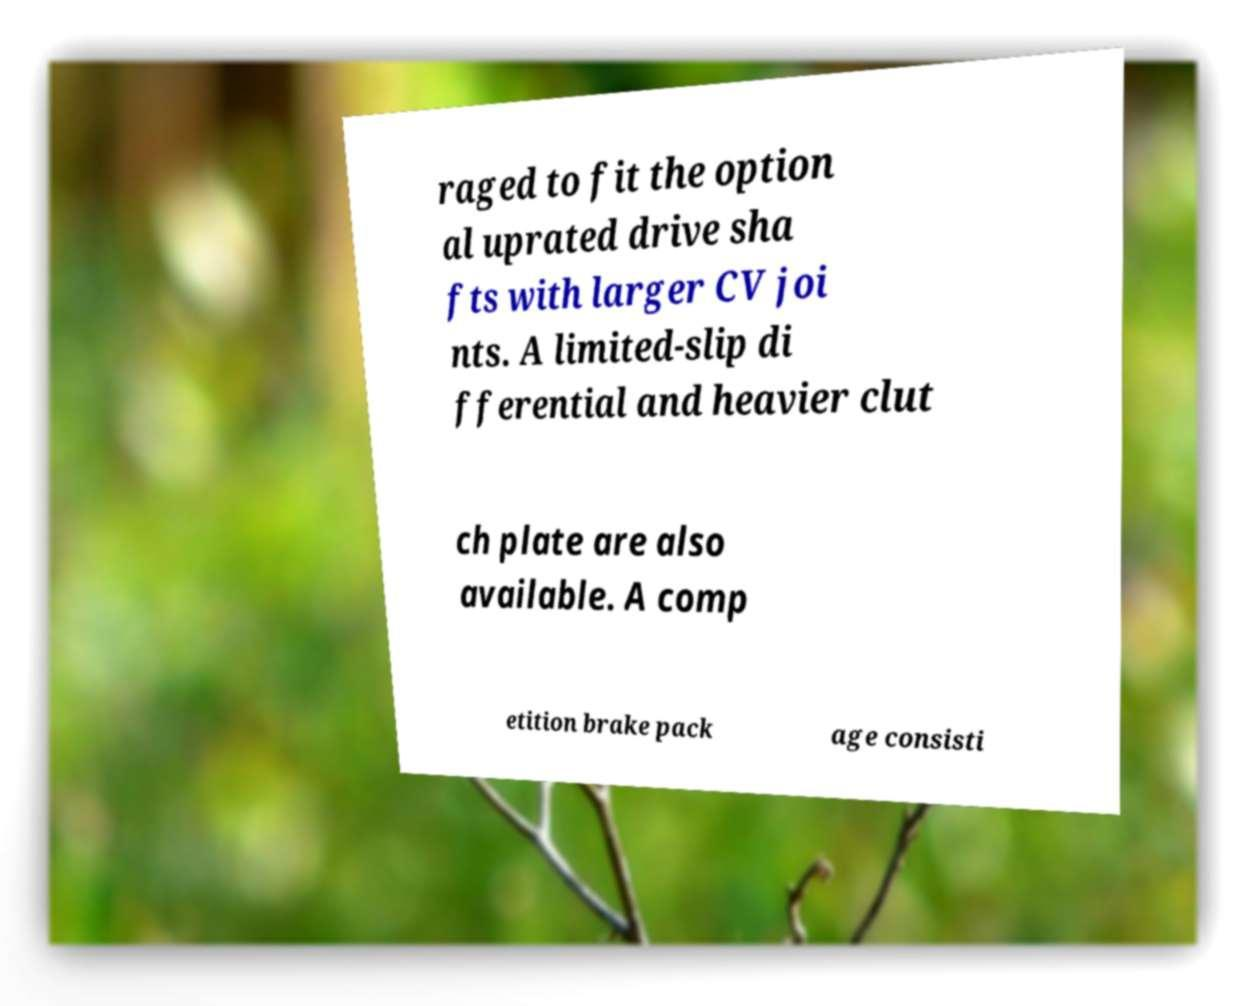Could you extract and type out the text from this image? raged to fit the option al uprated drive sha fts with larger CV joi nts. A limited-slip di fferential and heavier clut ch plate are also available. A comp etition brake pack age consisti 